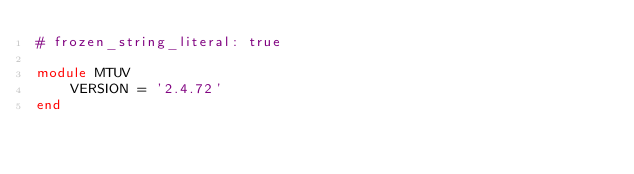Convert code to text. <code><loc_0><loc_0><loc_500><loc_500><_Ruby_># frozen_string_literal: true

module MTUV
    VERSION = '2.4.72'
end
</code> 